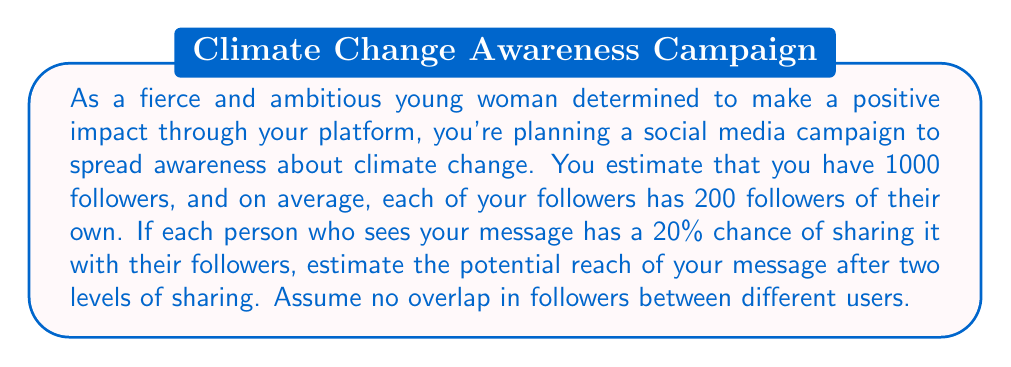Give your solution to this math problem. Let's break this down step-by-step:

1) Your initial reach:
   You have 1000 followers, so the initial reach is 1000 people.

2) First level of sharing:
   - Each of your 1000 followers has a 20% chance of sharing.
   - Expected number of shares: $1000 \times 0.20 = 200$ shares
   - Each share reaches 200 new people on average
   - Total reach from first level: $200 \times 200 = 40,000$ people

3) Second level of sharing:
   - The message has now reached $40,000$ new people
   - Each of these has a 20% chance of sharing
   - Expected number of shares: $40,000 \times 0.20 = 8,000$ shares
   - Each share reaches 200 new people on average
   - Total reach from second level: $8,000 \times 200 = 1,600,000$ people

4) Total potential reach:
   $$\text{Initial} + \text{First Level} + \text{Second Level}$$
   $$1,000 + 40,000 + 1,600,000 = 1,641,000$$

Therefore, the estimated potential reach after two levels of sharing is 1,641,000 people.
Answer: 1,641,000 people 